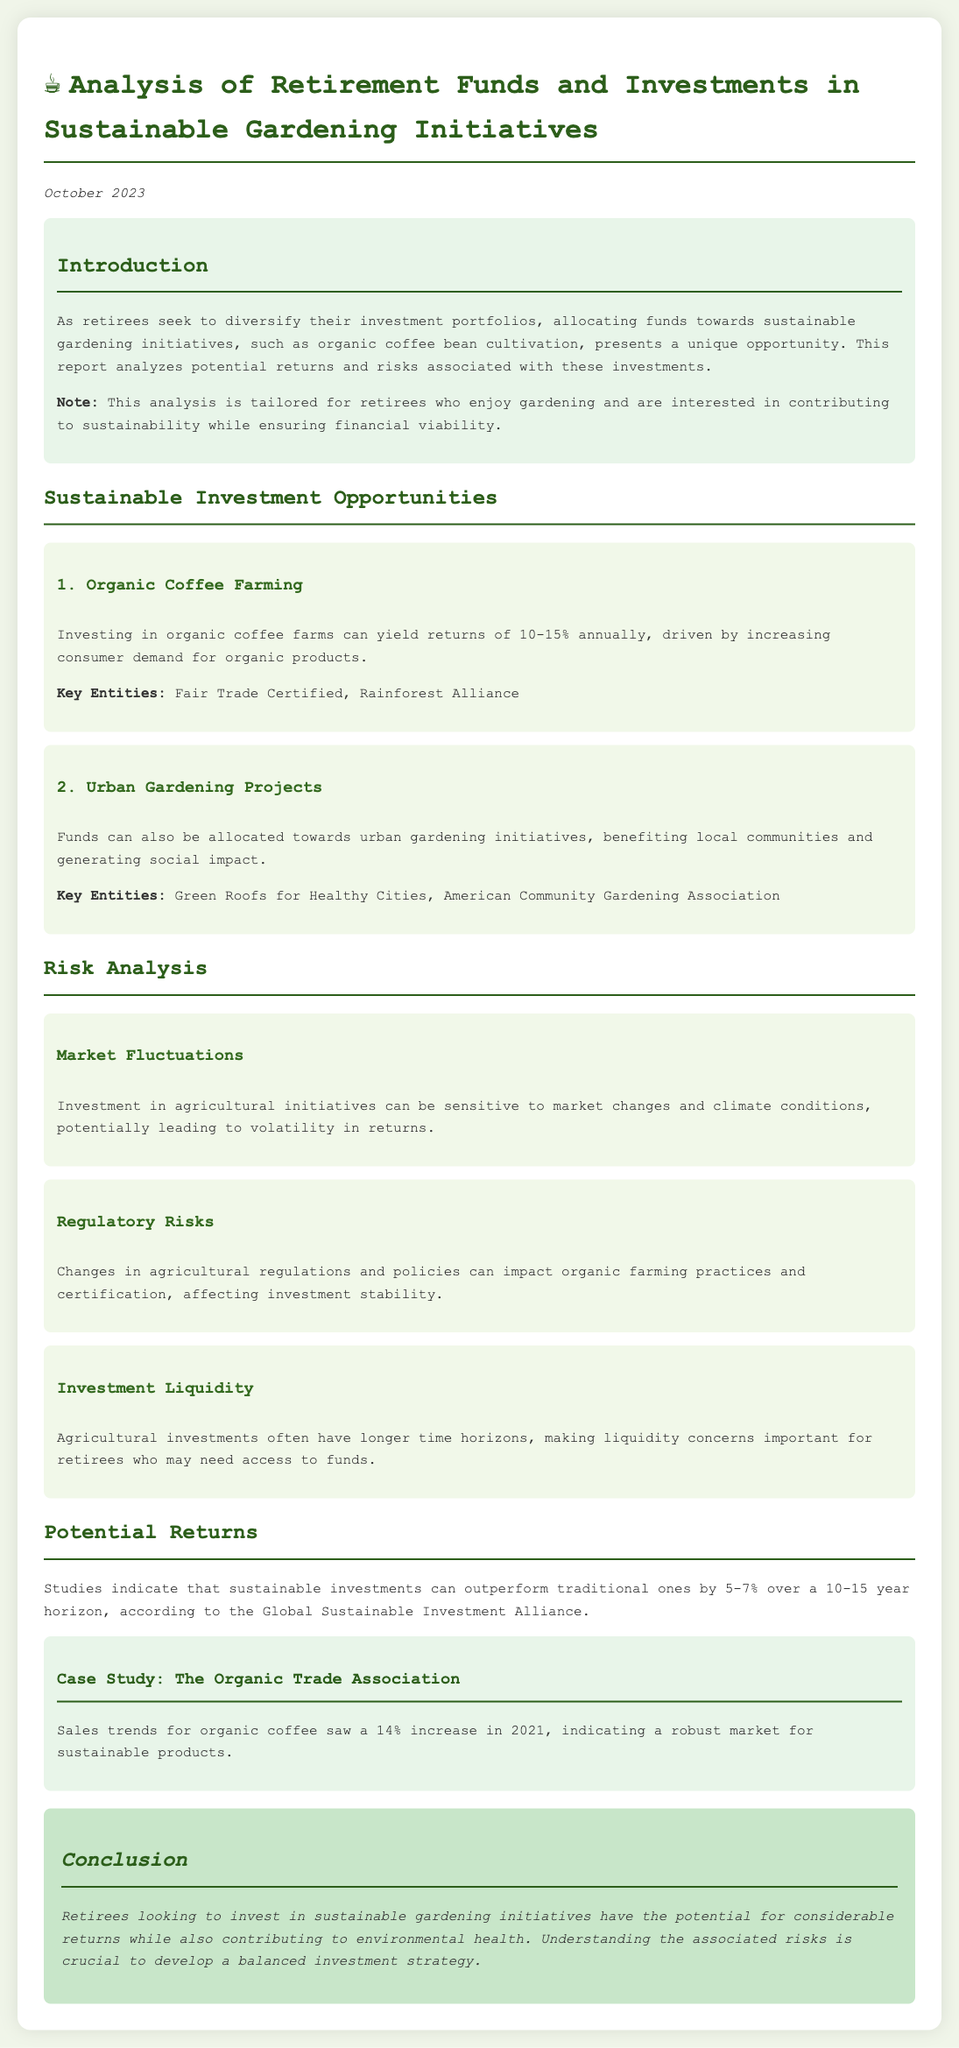What is the primary focus of the report? The report focuses on the analysis of retirement funds and investments in sustainable gardening initiatives.
Answer: Sustainable gardening initiatives What is the estimated annual return for organic coffee farming? The document states that investing in organic coffee farms can yield returns of 10-15% annually.
Answer: 10-15% What is one of the key entities mentioned for urban gardening projects? The document lists several key entities, one of which is the American Community Gardening Association.
Answer: American Community Gardening Association What increase in sales trends for organic coffee was noted in 2021? According to the case study, sales trends for organic coffee saw a 14% increase in 2021.
Answer: 14% What is one significant risk associated with agricultural investments? The document highlights several risks, including market fluctuations, which can lead to volatility in returns.
Answer: Market fluctuations How much can sustainable investments potentially outperform traditional ones over 10-15 years? The document indicates that sustainable investments can outperform traditional ones by 5-7%.
Answer: 5-7% What is the main conclusion drawn in the report? The conclusion emphasizes the potential for considerable returns for retirees investing in sustainable gardening while also addressing environmental health.
Answer: Considerable returns What is the publication date of the report? The report is dated October 2023.
Answer: October 2023 